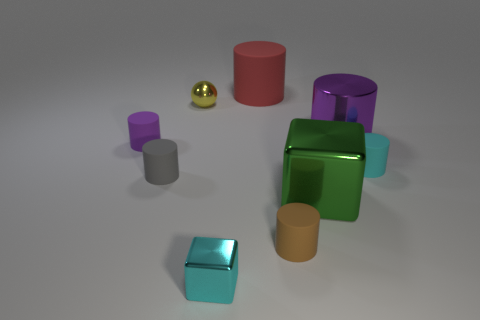Subtract all yellow balls. How many purple cylinders are left? 2 Subtract 1 cylinders. How many cylinders are left? 5 Subtract all cyan cylinders. How many cylinders are left? 5 Subtract all gray cylinders. How many cylinders are left? 5 Add 1 red matte things. How many objects exist? 10 Subtract all yellow cylinders. Subtract all gray cubes. How many cylinders are left? 6 Subtract all cylinders. How many objects are left? 3 Add 1 green things. How many green things exist? 2 Subtract 1 cyan cubes. How many objects are left? 8 Subtract all gray metallic blocks. Subtract all red rubber cylinders. How many objects are left? 8 